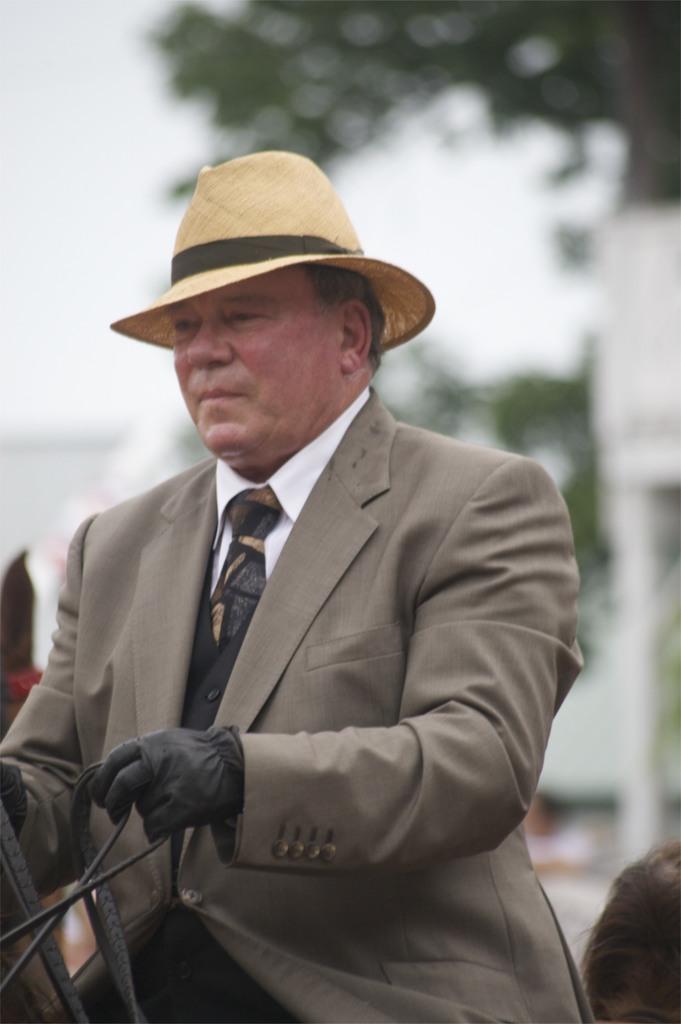Please provide a concise description of this image. In this image we can see a person wearing hat and gloves. He is holding rope. In the background it is blur. Near to him we can see head of a person. 